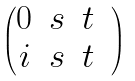<formula> <loc_0><loc_0><loc_500><loc_500>\begin{pmatrix} 0 & s & t & \\ i & s & t \end{pmatrix}</formula> 